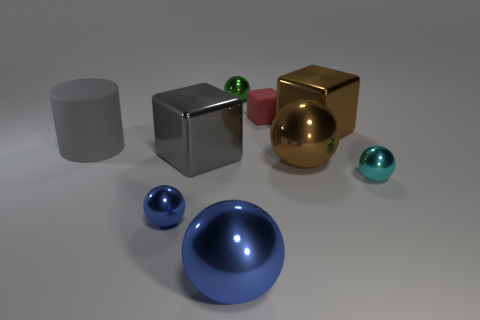There is a brown object that is the same shape as the cyan thing; what material is it?
Offer a terse response. Metal. There is a sphere that is left of the tiny green shiny object and behind the big blue sphere; what is its material?
Keep it short and to the point. Metal. Does the cylinder have the same color as the small ball on the left side of the big blue object?
Provide a succinct answer. No. There is a green thing that is the same size as the cyan metallic thing; what is it made of?
Provide a short and direct response. Metal. Is there another blue ball made of the same material as the big blue sphere?
Give a very brief answer. Yes. What number of brown metallic spheres are there?
Offer a terse response. 1. Are the big gray block and the small thing that is behind the red cube made of the same material?
Give a very brief answer. Yes. What is the material of the block that is the same color as the matte cylinder?
Your answer should be very brief. Metal. What number of tiny metal balls are the same color as the large rubber cylinder?
Ensure brevity in your answer.  0. The rubber cube is what size?
Make the answer very short. Small. 